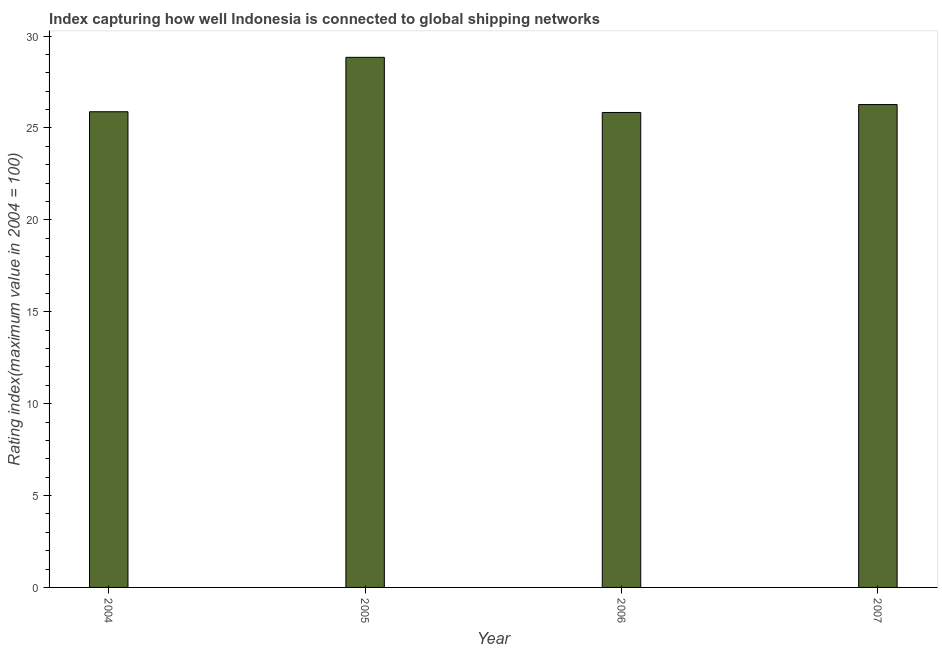Does the graph contain any zero values?
Give a very brief answer. No. Does the graph contain grids?
Provide a short and direct response. No. What is the title of the graph?
Give a very brief answer. Index capturing how well Indonesia is connected to global shipping networks. What is the label or title of the X-axis?
Offer a terse response. Year. What is the label or title of the Y-axis?
Provide a short and direct response. Rating index(maximum value in 2004 = 100). What is the liner shipping connectivity index in 2005?
Provide a succinct answer. 28.84. Across all years, what is the maximum liner shipping connectivity index?
Make the answer very short. 28.84. Across all years, what is the minimum liner shipping connectivity index?
Offer a terse response. 25.84. In which year was the liner shipping connectivity index minimum?
Keep it short and to the point. 2006. What is the sum of the liner shipping connectivity index?
Keep it short and to the point. 106.83. What is the difference between the liner shipping connectivity index in 2004 and 2005?
Give a very brief answer. -2.96. What is the average liner shipping connectivity index per year?
Your answer should be very brief. 26.71. What is the median liner shipping connectivity index?
Keep it short and to the point. 26.07. What is the ratio of the liner shipping connectivity index in 2004 to that in 2005?
Your answer should be compact. 0.9. What is the difference between the highest and the second highest liner shipping connectivity index?
Ensure brevity in your answer.  2.57. What is the Rating index(maximum value in 2004 = 100) in 2004?
Your answer should be compact. 25.88. What is the Rating index(maximum value in 2004 = 100) of 2005?
Keep it short and to the point. 28.84. What is the Rating index(maximum value in 2004 = 100) in 2006?
Make the answer very short. 25.84. What is the Rating index(maximum value in 2004 = 100) of 2007?
Keep it short and to the point. 26.27. What is the difference between the Rating index(maximum value in 2004 = 100) in 2004 and 2005?
Provide a short and direct response. -2.96. What is the difference between the Rating index(maximum value in 2004 = 100) in 2004 and 2006?
Offer a very short reply. 0.04. What is the difference between the Rating index(maximum value in 2004 = 100) in 2004 and 2007?
Keep it short and to the point. -0.39. What is the difference between the Rating index(maximum value in 2004 = 100) in 2005 and 2007?
Keep it short and to the point. 2.57. What is the difference between the Rating index(maximum value in 2004 = 100) in 2006 and 2007?
Your answer should be compact. -0.43. What is the ratio of the Rating index(maximum value in 2004 = 100) in 2004 to that in 2005?
Provide a short and direct response. 0.9. What is the ratio of the Rating index(maximum value in 2004 = 100) in 2004 to that in 2006?
Give a very brief answer. 1. What is the ratio of the Rating index(maximum value in 2004 = 100) in 2004 to that in 2007?
Your answer should be very brief. 0.98. What is the ratio of the Rating index(maximum value in 2004 = 100) in 2005 to that in 2006?
Your answer should be very brief. 1.12. What is the ratio of the Rating index(maximum value in 2004 = 100) in 2005 to that in 2007?
Your answer should be very brief. 1.1. 